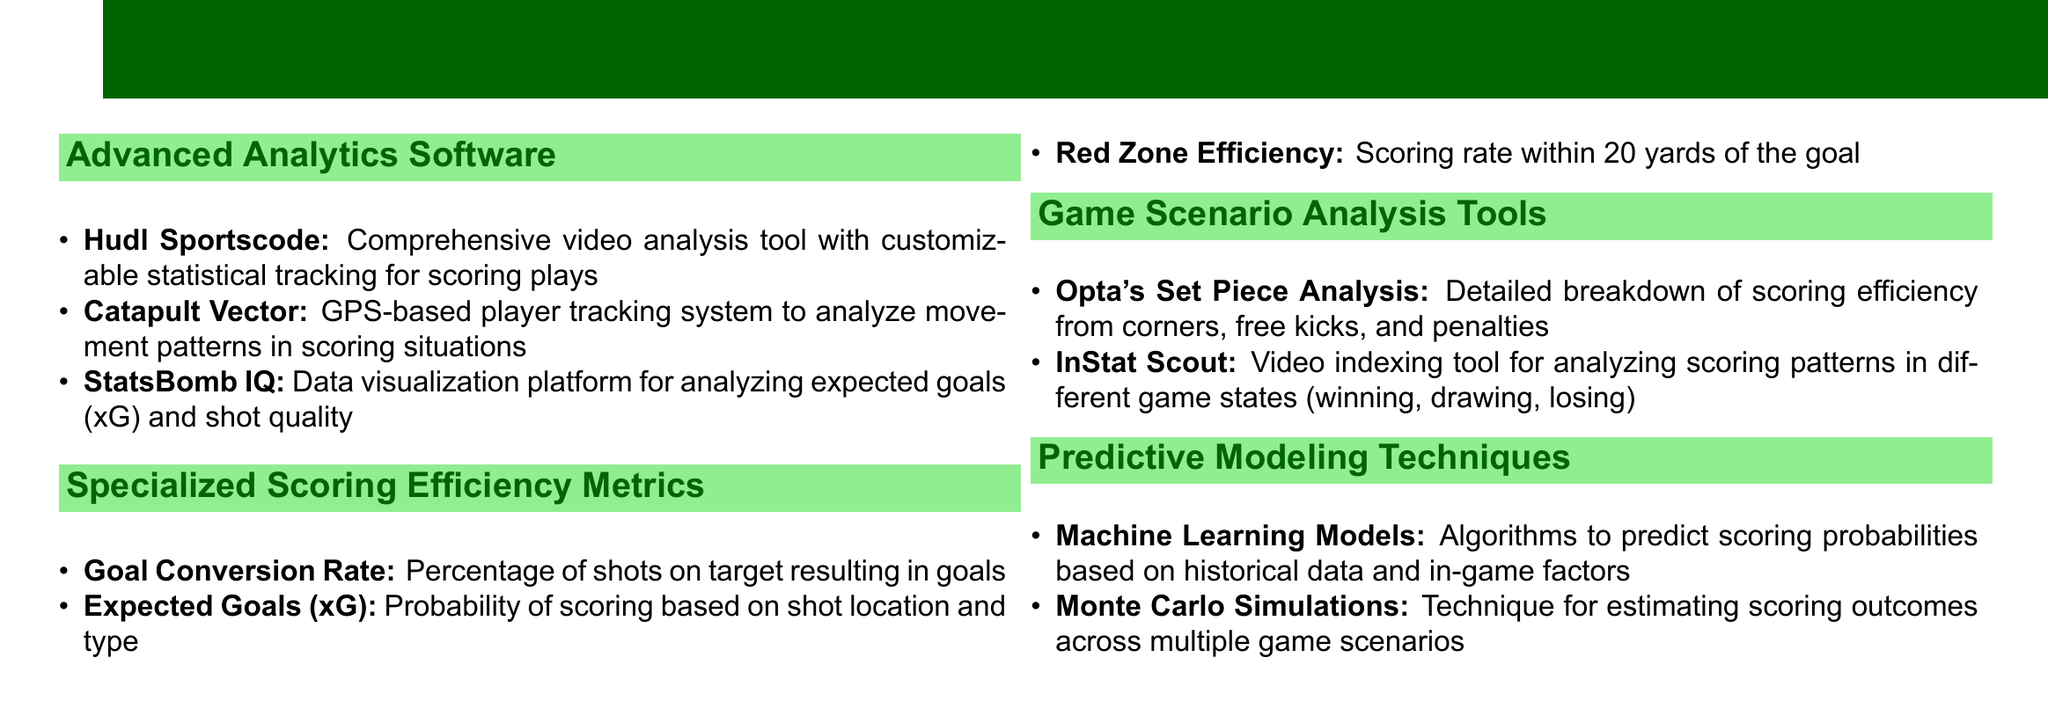What is the primary focus of the catalog? The catalog is dedicated to statistical analysis tools aimed at optimizing scoring efficiency in football.
Answer: Optimizing scoring efficiency in football How many categories of tools are listed in the document? The document contains four categories of statistical analysis tools.
Answer: Four What does the "Expected Goals (xG)" metric represent? This metric indicates the probability of scoring based on shot location and type.
Answer: Probability of scoring based on shot location and type Which tool provides a breakdown of scoring efficiency from set pieces? Opta's Set Piece Analysis is the tool that offers this breakdown.
Answer: Opta's Set Piece Analysis What technique is used for estimating scoring outcomes across multiple game scenarios? Monte Carlo Simulations are used for this purpose.
Answer: Monte Carlo Simulations Which software is mentioned for video analysis of scoring plays? Hudl Sportscode is the video analysis tool referenced in the document.
Answer: Hudl Sportscode What metric pertains to the scoring rate within 20 yards of the goal? Red Zone Efficiency is the metric related to this scoring rate.
Answer: Red Zone Efficiency Which system tracks player movement patterns in scoring situations? Catapult Vector is the system that tracks player movements.
Answer: Catapult Vector 